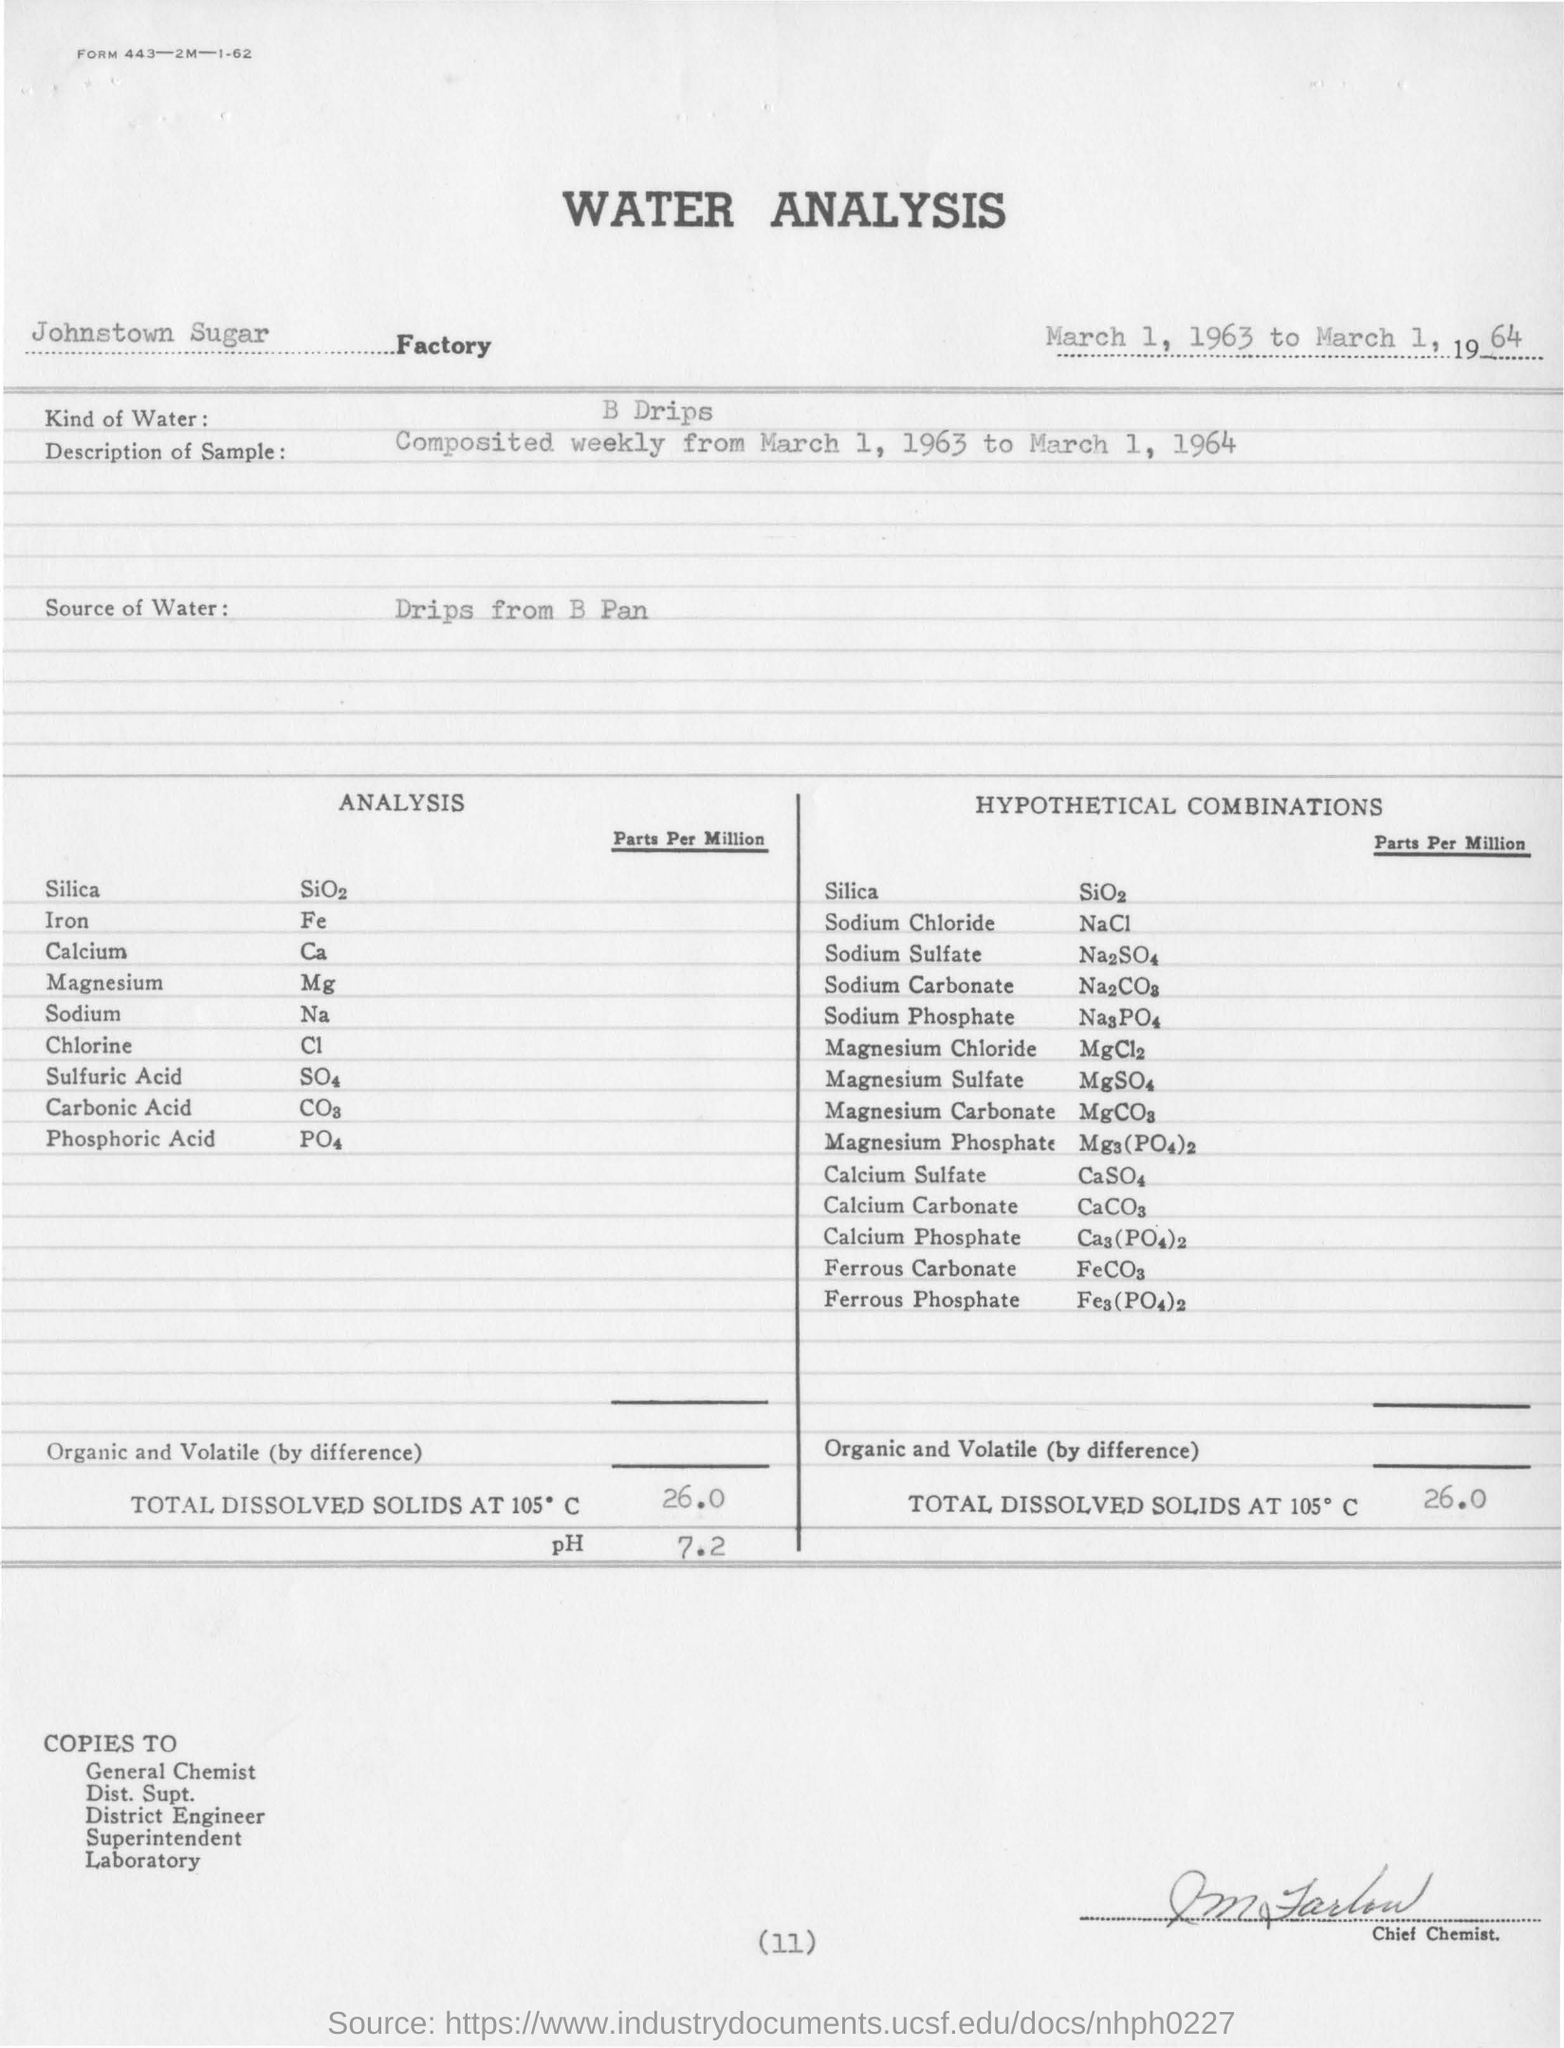Indicate a few pertinent items in this graphic. The total dissolved solids present in the water sample at 105 degrees Celsius are 260 parts per million. The total dissolved solids present at 105 degrees Celsius are 26.0 parts per million in a hypothetical combination. Water samples used for analysis are typically obtained from a reliable source, such as a well or tap, and are of high quality to ensure accurate results. The pH value for water that has been conducted through a B Drip system is 7.2. The "description of sample" refers to a composite that was created by combining several individual data points over the course of a year. Specifically, it was composed by taking weekly data from March 1, 1963 to March 1, 1964 and combining them into a single, comprehensive figure. 